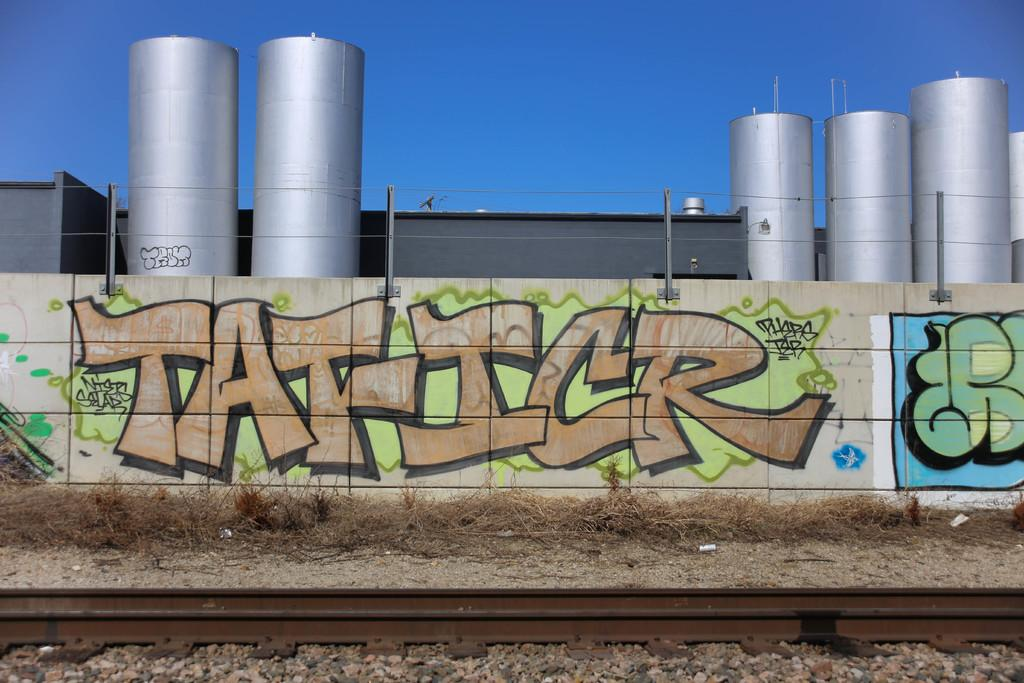<image>
Present a compact description of the photo's key features. An industrial plant has graffiti on it that reads Tat-Icr. 